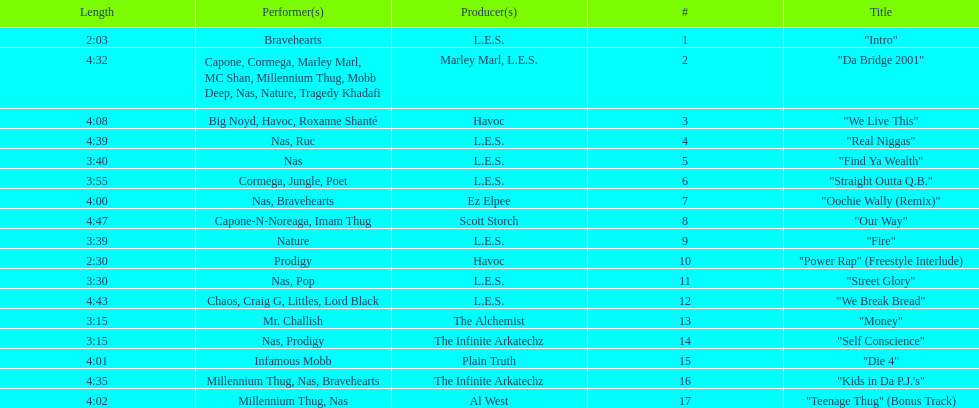How long os the longest track on the album? 4:47. 